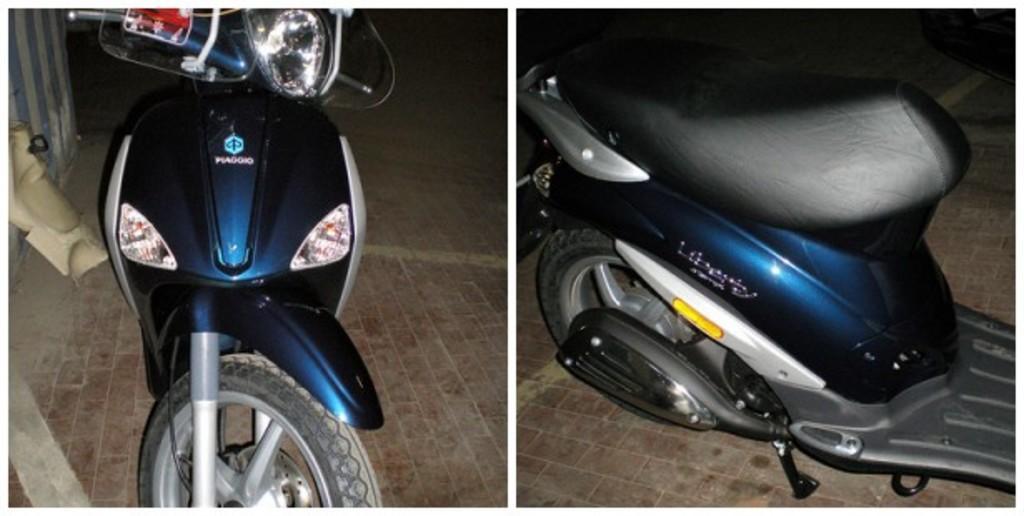Could you give a brief overview of what you see in this image? This is collage picture,in these two pictures we can see scooters. On the left side of the image we can see wall. 